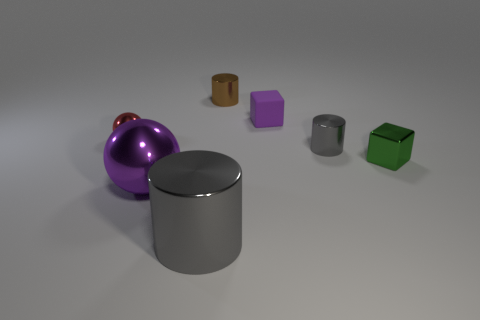Subtract all tiny cylinders. How many cylinders are left? 1 Subtract all red balls. How many balls are left? 1 Subtract all blocks. How many objects are left? 5 Add 3 tiny matte cubes. How many objects exist? 10 Subtract all big metallic cubes. Subtract all gray objects. How many objects are left? 5 Add 4 small metallic cylinders. How many small metallic cylinders are left? 6 Add 3 metallic cylinders. How many metallic cylinders exist? 6 Subtract 0 cyan spheres. How many objects are left? 7 Subtract 3 cylinders. How many cylinders are left? 0 Subtract all purple cubes. Subtract all red balls. How many cubes are left? 1 